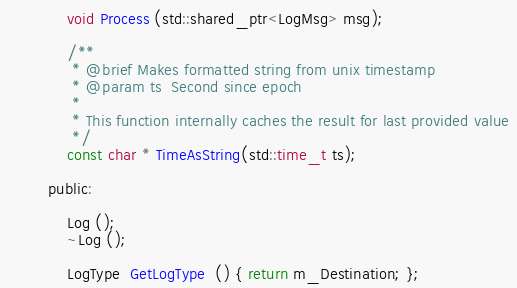Convert code to text. <code><loc_0><loc_0><loc_500><loc_500><_C_>			void Process (std::shared_ptr<LogMsg> msg);

			/**
			 * @brief Makes formatted string from unix timestamp
			 * @param ts  Second since epoch
			 *
			 * This function internally caches the result for last provided value
			 */
			const char * TimeAsString(std::time_t ts);

		public:

			Log ();
			~Log ();

			LogType  GetLogType  () { return m_Destination; };</code> 